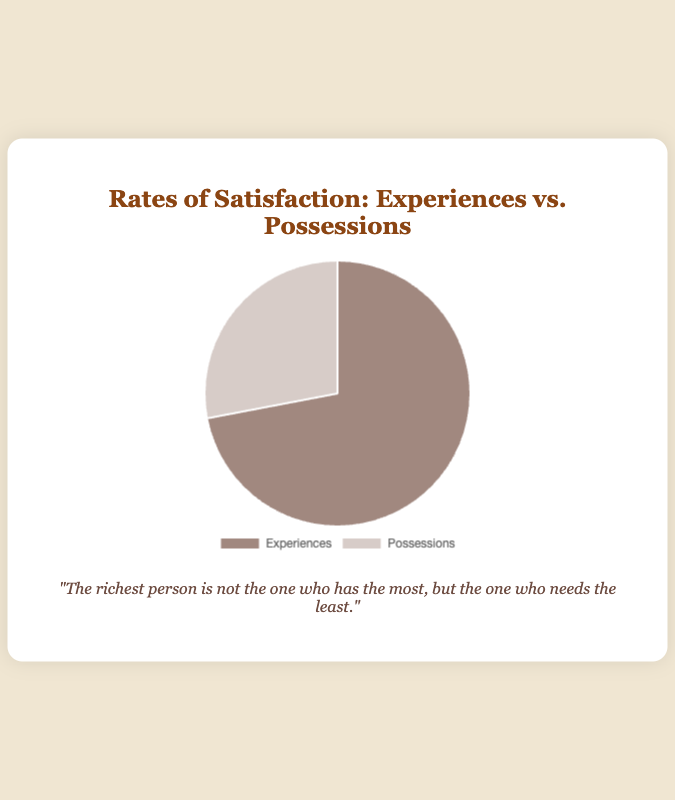What are the percentage rates of satisfaction for experiences and possessions? The pie chart shows two data points: "Experiences" with 72% and "Possessions" with 28%. Both values are labeled on the chart.
Answer: 72% for experiences, 28% for possessions Which category has a higher satisfaction rate? Comparing the two percentages shown, "Experiences" has a higher satisfaction rate (72%) compared to "Possessions" (28%).
Answer: Experiences How much greater is the satisfaction rate for experiences compared to possessions? Subtract the percentage of "Possessions" from "Experiences": 72% - 28% = 44%.
Answer: 44% What fraction of the total satisfaction does the possessions category represent? Convert the possession satisfaction rate into a fraction: 28% can be represented as 28/100, which simplifies to 7/25.
Answer: 7/25 If you were to combine both categories, what would be the total percentage? Add the percentages of the two categories: 72% + 28% = 100%.
Answer: 100% In terms of visual representation, what colors are used for each category in the pie chart? "Experiences" is represented in a brownish color, while "Possessions" is in a light taupe color.
Answer: Brownish for experiences, light taupe for possessions If the satisfaction rates were to balance equally between experiences and possessions, what would the necessary value adjustment be for each category? To balance equally, each category needs to represent 50%. For "Experiences": 72% - 50% = 22% decrease. For "Possessions": 50% - 28% = 22% increase.
Answer: 22% decrease for experiences, 22% increase for possessions What is the combined total satisfaction rate if possessions increased by 2% and experiences decreased by 2%? Subtract 2% from experiences: 72% - 2% = 70%. Add 2% to possessions: 28% + 2% = 30%. The combined total remains 70% + 30% = 100%.
Answer: 100% How does the quote "The richest person is not the one who has the most, but the one who needs the least" relate to the data presented in the chart? The data indicates higher satisfaction rates with experiences over possessions, aligning with the quote's theme that fulfillment and wealth are not based on material possessions but on other aspects of life such as experiences.
Answer: Aligns with the data showing higher satisfaction with experiences 